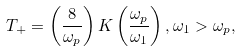<formula> <loc_0><loc_0><loc_500><loc_500>T _ { + } = \left ( \frac { 8 } { \omega _ { p } } \right ) K \left ( \frac { \omega _ { p } } { \omega _ { 1 } } \right ) , \omega _ { 1 } > \omega _ { p } ,</formula> 